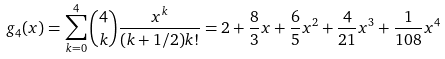<formula> <loc_0><loc_0><loc_500><loc_500>g _ { 4 } ( x ) = \sum _ { k = 0 } ^ { 4 } \binom { 4 } { k } \frac { x ^ { k } } { ( k + 1 / 2 ) k ! } = 2 + \frac { 8 } { 3 } x + \frac { 6 } { 5 } x ^ { 2 } + \frac { 4 } { 2 1 } x ^ { 3 } + \frac { 1 } { 1 0 8 } x ^ { 4 }</formula> 